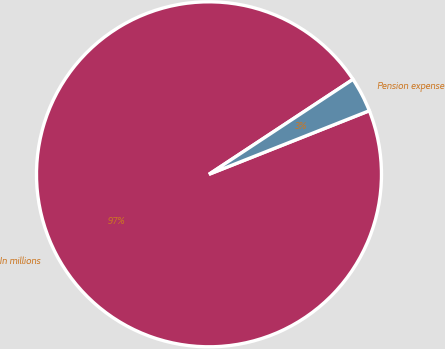Convert chart to OTSL. <chart><loc_0><loc_0><loc_500><loc_500><pie_chart><fcel>In millions<fcel>Pension expense<nl><fcel>96.73%<fcel>3.27%<nl></chart> 